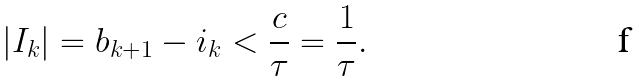<formula> <loc_0><loc_0><loc_500><loc_500>| I _ { k } | = b _ { k + 1 } - i _ { k } < \frac { c } { \tau } = \frac { 1 } { \tau } .</formula> 